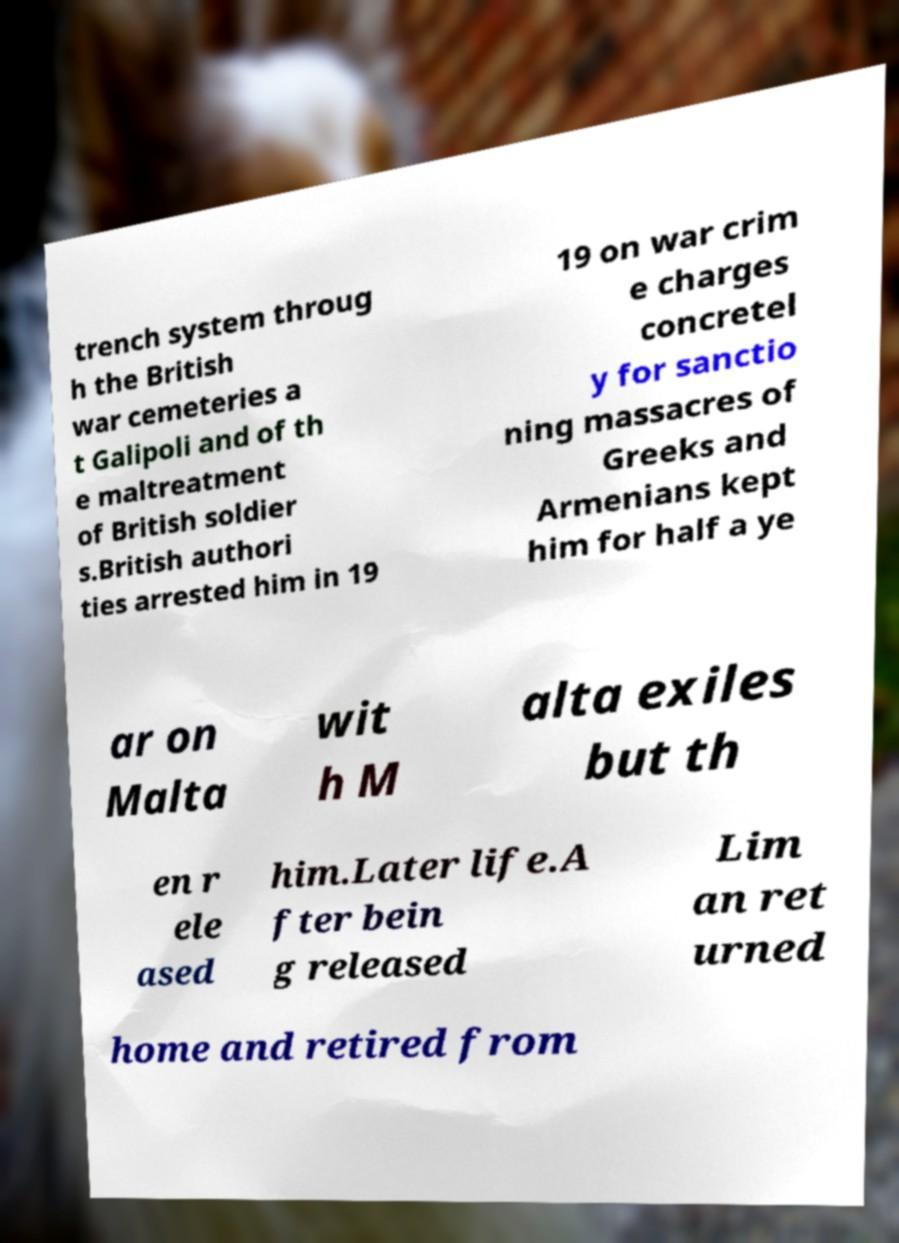Could you assist in decoding the text presented in this image and type it out clearly? trench system throug h the British war cemeteries a t Galipoli and of th e maltreatment of British soldier s.British authori ties arrested him in 19 19 on war crim e charges concretel y for sanctio ning massacres of Greeks and Armenians kept him for half a ye ar on Malta wit h M alta exiles but th en r ele ased him.Later life.A fter bein g released Lim an ret urned home and retired from 